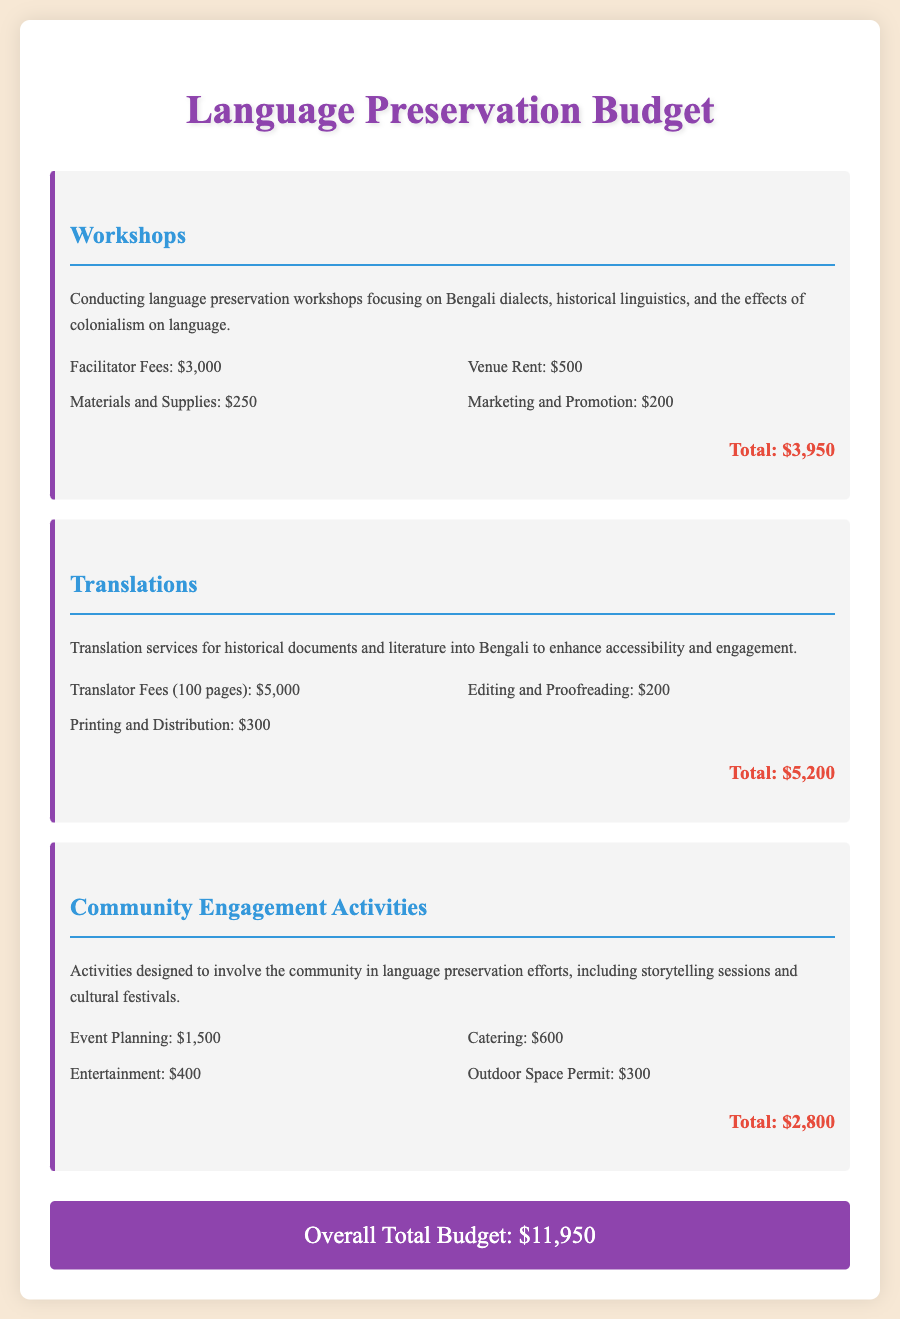What is the total cost for workshops? The total cost for workshops is mentioned directly in the budget section for workshops.
Answer: $3,950 How much is allocated for translator fees? The document specifies the translator fees in the translations budget section.
Answer: $5,000 What is the budget for community engagement activities? The total budget for community engagement activities is clearly stated in the respective section.
Answer: $2,800 What are the costs associated with materials and supplies for workshops? The cost for materials and supplies is listed under the workshops budget item.
Answer: $250 What is the overall total budget for all initiatives? The overall total budget provides the cumulative figure for all sections combined at the end of the document.
Answer: $11,950 How much is spent on marketing and promotion in workshops? The budget details for workshops include a specific amount for marketing and promotion.
Answer: $200 What is included in the budget for catering under community engagement activities? The budget outlines individual costs, and catering is one of the specified expenses under community engagement activities.
Answer: $600 What type of activities are included under community engagement? The document describes the nature of activities planned for community engagement.
Answer: storytelling sessions and cultural festivals 